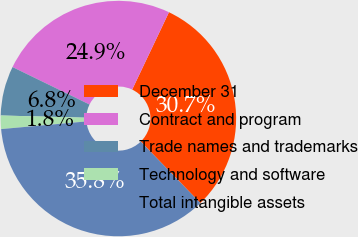<chart> <loc_0><loc_0><loc_500><loc_500><pie_chart><fcel>December 31<fcel>Contract and program<fcel>Trade names and trademarks<fcel>Technology and software<fcel>Total intangible assets<nl><fcel>30.68%<fcel>24.86%<fcel>6.79%<fcel>1.84%<fcel>35.83%<nl></chart> 